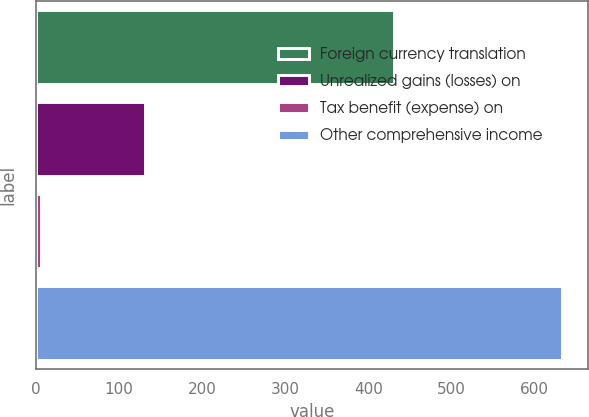Convert chart. <chart><loc_0><loc_0><loc_500><loc_500><bar_chart><fcel>Foreign currency translation<fcel>Unrealized gains (losses) on<fcel>Tax benefit (expense) on<fcel>Other comprehensive income<nl><fcel>431<fcel>131.4<fcel>6<fcel>633<nl></chart> 